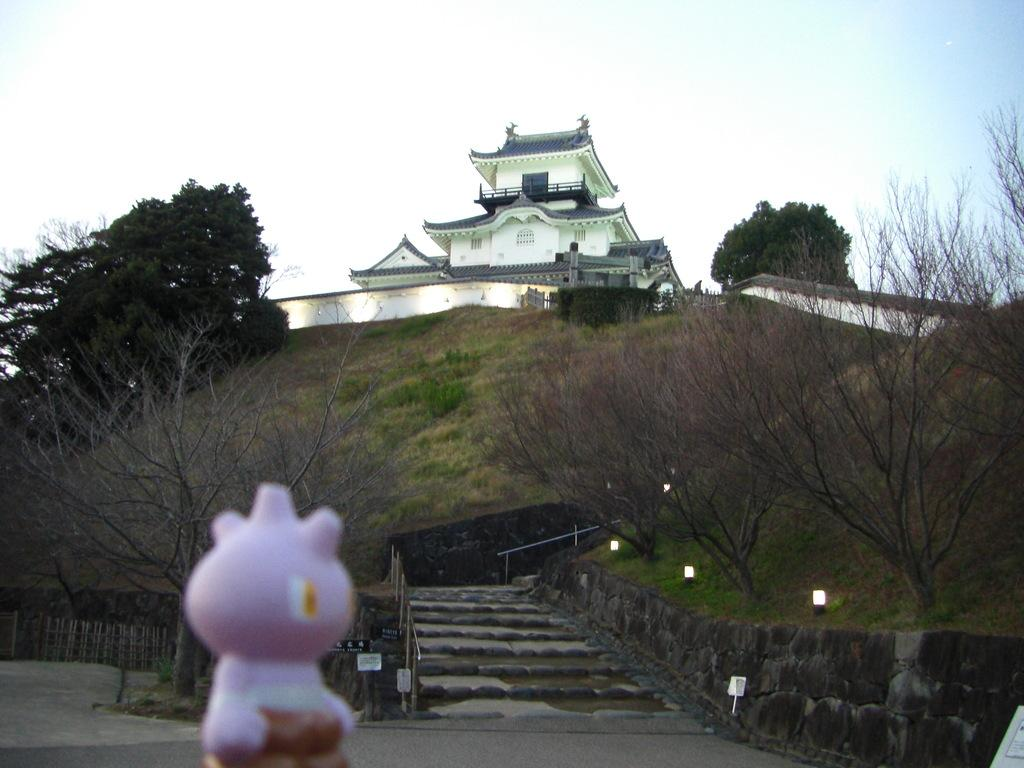What type of structure is visible in the image? There is a building in the image. What type of vegetation can be seen in the image? There are trees and grass in the image. What architectural feature is present in the image? There is a staircase in the image. What type of barrier is visible in the image? There is a wall in the image. What type of illumination is present in the image? There are lights in the image. What part of the natural environment is visible in the image? The sky is visible at the top of the image. What type of object is present in the image that is typically associated with play? There is a toy in the image. What type of transportation infrastructure is visible in the image? There is a road in the image. How many team members are visible in the image? There are no team members present in the image. What type of bikes can be seen in the image? There are no bikes present in the image. 